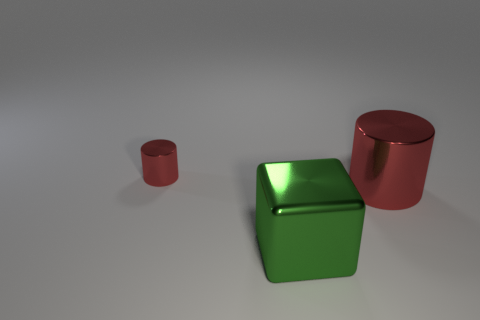Add 2 big metallic cubes. How many objects exist? 5 Subtract all blocks. How many objects are left? 2 Subtract all brown blocks. Subtract all brown cylinders. How many blocks are left? 1 Subtract all large red metallic cylinders. Subtract all big gray objects. How many objects are left? 2 Add 1 small red things. How many small red things are left? 2 Add 3 large green things. How many large green things exist? 4 Subtract 0 red spheres. How many objects are left? 3 